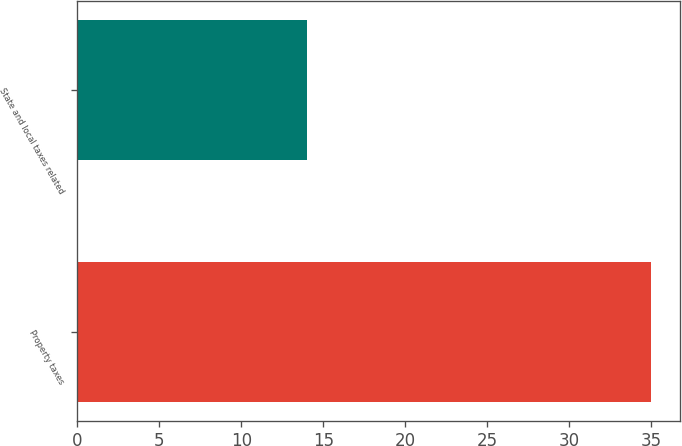Convert chart to OTSL. <chart><loc_0><loc_0><loc_500><loc_500><bar_chart><fcel>Property taxes<fcel>State and local taxes related<nl><fcel>35<fcel>14<nl></chart> 